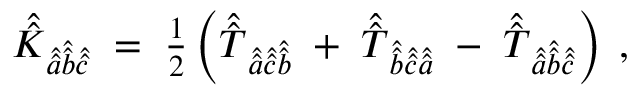Convert formula to latex. <formula><loc_0><loc_0><loc_500><loc_500>\hat { \hat { K } } _ { \hat { \hat { a } } \hat { \hat { b } } \hat { \hat { c } } } \, = \, { \frac { 1 } { 2 } } \left ( \hat { \hat { T } } _ { \hat { \hat { a } } \hat { \hat { c } } \hat { \hat { b } } } \, + \, \hat { \hat { T } } _ { \hat { \hat { b } } \hat { \hat { c } } \hat { \hat { a } } } \, - \, \hat { \hat { T } } _ { \hat { \hat { a } } \hat { \hat { b } } \hat { \hat { c } } } \right ) \, ,</formula> 